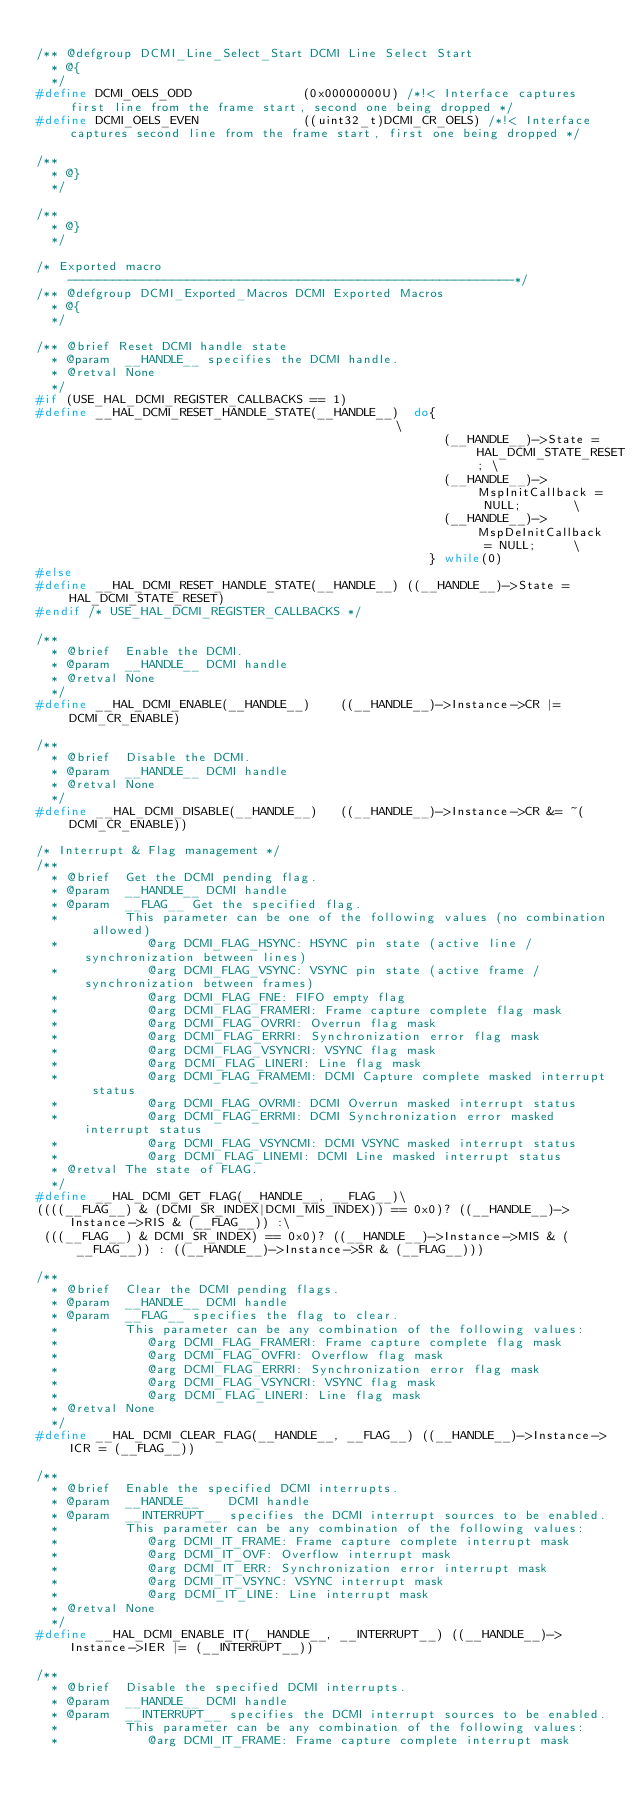Convert code to text. <code><loc_0><loc_0><loc_500><loc_500><_C_>
/** @defgroup DCMI_Line_Select_Start DCMI Line Select Start
  * @{
  */
#define DCMI_OELS_ODD               (0x00000000U) /*!< Interface captures first line from the frame start, second one being dropped */
#define DCMI_OELS_EVEN              ((uint32_t)DCMI_CR_OELS) /*!< Interface captures second line from the frame start, first one being dropped */

/**
  * @}
  */

/**
  * @}
  */

/* Exported macro ------------------------------------------------------------*/
/** @defgroup DCMI_Exported_Macros DCMI Exported Macros
  * @{
  */

/** @brief Reset DCMI handle state
  * @param  __HANDLE__ specifies the DCMI handle.
  * @retval None
  */
#if (USE_HAL_DCMI_REGISTER_CALLBACKS == 1)
#define __HAL_DCMI_RESET_HANDLE_STATE(__HANDLE__)  do{                                             \
                                                       (__HANDLE__)->State = HAL_DCMI_STATE_RESET; \
                                                       (__HANDLE__)->MspInitCallback = NULL;       \
                                                       (__HANDLE__)->MspDeInitCallback = NULL;     \
                                                     } while(0)
#else
#define __HAL_DCMI_RESET_HANDLE_STATE(__HANDLE__) ((__HANDLE__)->State = HAL_DCMI_STATE_RESET)
#endif /* USE_HAL_DCMI_REGISTER_CALLBACKS */

/**
  * @brief  Enable the DCMI.
  * @param  __HANDLE__ DCMI handle
  * @retval None
  */
#define __HAL_DCMI_ENABLE(__HANDLE__)    ((__HANDLE__)->Instance->CR |= DCMI_CR_ENABLE)

/**
  * @brief  Disable the DCMI.
  * @param  __HANDLE__ DCMI handle
  * @retval None
  */
#define __HAL_DCMI_DISABLE(__HANDLE__)   ((__HANDLE__)->Instance->CR &= ~(DCMI_CR_ENABLE))

/* Interrupt & Flag management */
/**
  * @brief  Get the DCMI pending flag.
  * @param  __HANDLE__ DCMI handle
  * @param  __FLAG__ Get the specified flag.
  *         This parameter can be one of the following values (no combination allowed)
  *            @arg DCMI_FLAG_HSYNC: HSYNC pin state (active line / synchronization between lines)
  *            @arg DCMI_FLAG_VSYNC: VSYNC pin state (active frame / synchronization between frames)
  *            @arg DCMI_FLAG_FNE: FIFO empty flag
  *            @arg DCMI_FLAG_FRAMERI: Frame capture complete flag mask
  *            @arg DCMI_FLAG_OVRRI: Overrun flag mask
  *            @arg DCMI_FLAG_ERRRI: Synchronization error flag mask
  *            @arg DCMI_FLAG_VSYNCRI: VSYNC flag mask
  *            @arg DCMI_FLAG_LINERI: Line flag mask
  *            @arg DCMI_FLAG_FRAMEMI: DCMI Capture complete masked interrupt status
  *            @arg DCMI_FLAG_OVRMI: DCMI Overrun masked interrupt status
  *            @arg DCMI_FLAG_ERRMI: DCMI Synchronization error masked interrupt status
  *            @arg DCMI_FLAG_VSYNCMI: DCMI VSYNC masked interrupt status
  *            @arg DCMI_FLAG_LINEMI: DCMI Line masked interrupt status
  * @retval The state of FLAG.
  */
#define __HAL_DCMI_GET_FLAG(__HANDLE__, __FLAG__)\
((((__FLAG__) & (DCMI_SR_INDEX|DCMI_MIS_INDEX)) == 0x0)? ((__HANDLE__)->Instance->RIS & (__FLAG__)) :\
 (((__FLAG__) & DCMI_SR_INDEX) == 0x0)? ((__HANDLE__)->Instance->MIS & (__FLAG__)) : ((__HANDLE__)->Instance->SR & (__FLAG__)))

/**
  * @brief  Clear the DCMI pending flags.
  * @param  __HANDLE__ DCMI handle
  * @param  __FLAG__ specifies the flag to clear.
  *         This parameter can be any combination of the following values:
  *            @arg DCMI_FLAG_FRAMERI: Frame capture complete flag mask
  *            @arg DCMI_FLAG_OVFRI: Overflow flag mask
  *            @arg DCMI_FLAG_ERRRI: Synchronization error flag mask
  *            @arg DCMI_FLAG_VSYNCRI: VSYNC flag mask
  *            @arg DCMI_FLAG_LINERI: Line flag mask
  * @retval None
  */
#define __HAL_DCMI_CLEAR_FLAG(__HANDLE__, __FLAG__) ((__HANDLE__)->Instance->ICR = (__FLAG__))

/**
  * @brief  Enable the specified DCMI interrupts.
  * @param  __HANDLE__    DCMI handle
  * @param  __INTERRUPT__ specifies the DCMI interrupt sources to be enabled.
  *         This parameter can be any combination of the following values:
  *            @arg DCMI_IT_FRAME: Frame capture complete interrupt mask
  *            @arg DCMI_IT_OVF: Overflow interrupt mask
  *            @arg DCMI_IT_ERR: Synchronization error interrupt mask
  *            @arg DCMI_IT_VSYNC: VSYNC interrupt mask
  *            @arg DCMI_IT_LINE: Line interrupt mask
  * @retval None
  */
#define __HAL_DCMI_ENABLE_IT(__HANDLE__, __INTERRUPT__) ((__HANDLE__)->Instance->IER |= (__INTERRUPT__))

/**
  * @brief  Disable the specified DCMI interrupts.
  * @param  __HANDLE__ DCMI handle
  * @param  __INTERRUPT__ specifies the DCMI interrupt sources to be enabled.
  *         This parameter can be any combination of the following values:
  *            @arg DCMI_IT_FRAME: Frame capture complete interrupt mask</code> 